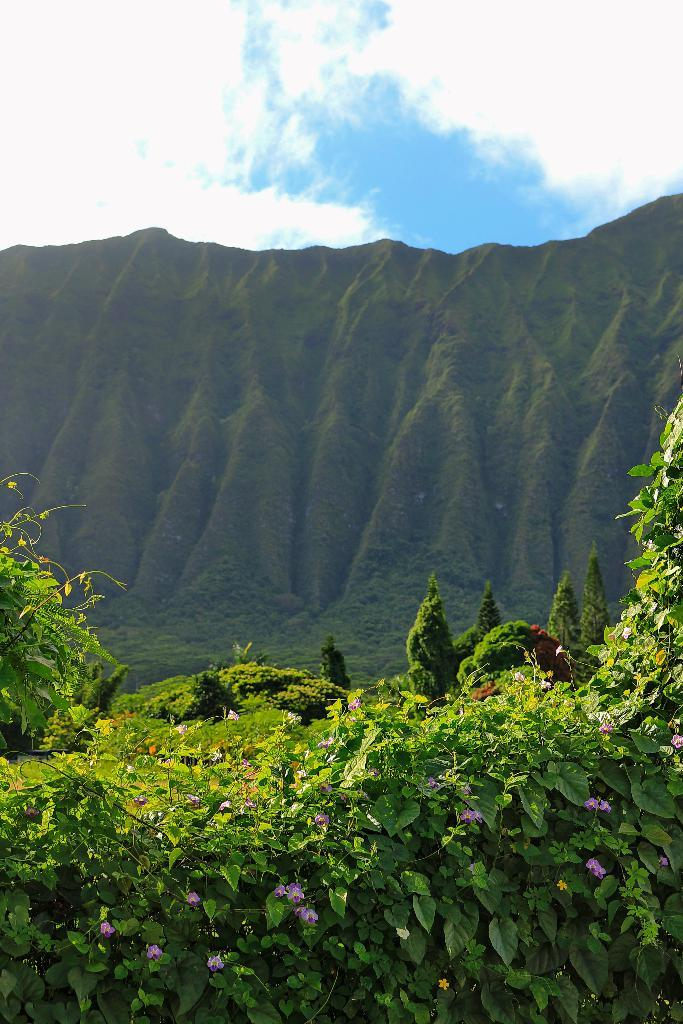What type of plants can be seen in the image? There are purple colorful plants in the image. What can be seen in the background of the image? There are trees, mountains, clouds, and the sky visible in the background of the image. What type of brass instrument is being played in the image? There is no brass instrument or any musical instrument present in the image. 